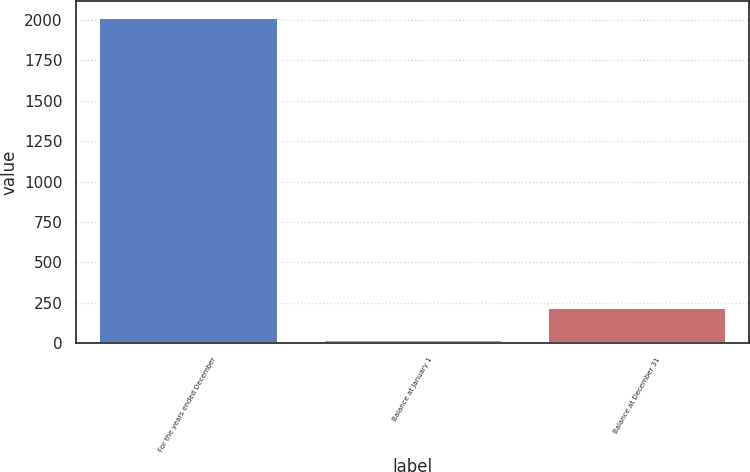<chart> <loc_0><loc_0><loc_500><loc_500><bar_chart><fcel>For the years ended December<fcel>Balance at January 1<fcel>Balance at December 31<nl><fcel>2016<fcel>22<fcel>221.4<nl></chart> 